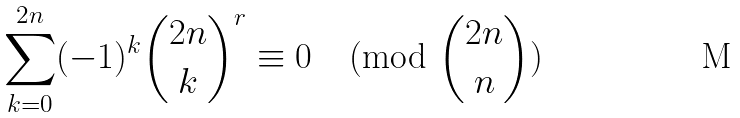Convert formula to latex. <formula><loc_0><loc_0><loc_500><loc_500>\sum _ { k = 0 } ^ { 2 n } ( - 1 ) ^ { k } \binom { 2 n } { k } ^ { r } \equiv 0 \pmod { \binom { 2 n } { n } }</formula> 